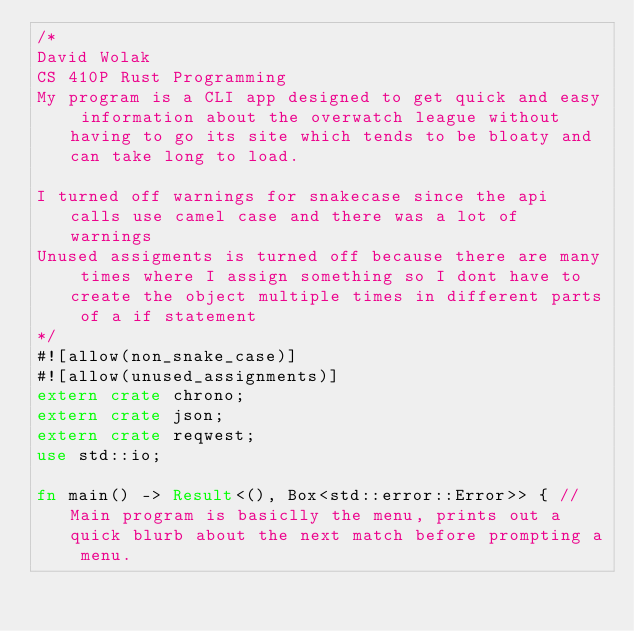Convert code to text. <code><loc_0><loc_0><loc_500><loc_500><_Rust_>/*
David Wolak
CS 410P Rust Programming
My program is a CLI app designed to get quick and easy information about the overwatch league without having to go its site which tends to be bloaty and can take long to load.

I turned off warnings for snakecase since the api calls use camel case and there was a lot of warnings
Unused assigments is turned off because there are many times where I assign something so I dont have to create the object multiple times in different parts of a if statement
*/
#![allow(non_snake_case)]
#![allow(unused_assignments)]
extern crate chrono;
extern crate json;
extern crate reqwest;
use std::io;

fn main() -> Result<(), Box<std::error::Error>> { //Main program is basiclly the menu, prints out a quick blurb about the next match before prompting a menu.</code> 